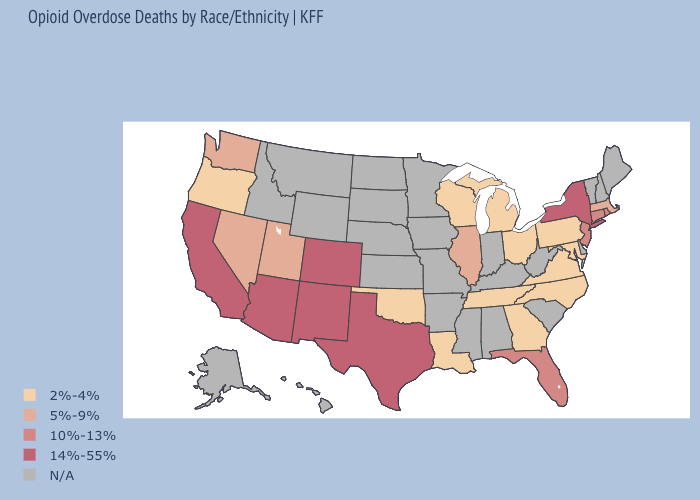Among the states that border Massachusetts , does Rhode Island have the highest value?
Concise answer only. No. Name the states that have a value in the range 2%-4%?
Answer briefly. Georgia, Louisiana, Maryland, Michigan, North Carolina, Ohio, Oklahoma, Oregon, Pennsylvania, Tennessee, Virginia, Wisconsin. Does the first symbol in the legend represent the smallest category?
Short answer required. Yes. Among the states that border Kansas , which have the highest value?
Write a very short answer. Colorado. What is the highest value in the MidWest ?
Keep it brief. 5%-9%. Name the states that have a value in the range N/A?
Give a very brief answer. Alabama, Alaska, Arkansas, Delaware, Hawaii, Idaho, Indiana, Iowa, Kansas, Kentucky, Maine, Minnesota, Mississippi, Missouri, Montana, Nebraska, New Hampshire, North Dakota, South Carolina, South Dakota, Vermont, West Virginia, Wyoming. What is the value of Mississippi?
Answer briefly. N/A. What is the value of Connecticut?
Answer briefly. 10%-13%. Name the states that have a value in the range 2%-4%?
Concise answer only. Georgia, Louisiana, Maryland, Michigan, North Carolina, Ohio, Oklahoma, Oregon, Pennsylvania, Tennessee, Virginia, Wisconsin. What is the value of Mississippi?
Answer briefly. N/A. Name the states that have a value in the range 2%-4%?
Quick response, please. Georgia, Louisiana, Maryland, Michigan, North Carolina, Ohio, Oklahoma, Oregon, Pennsylvania, Tennessee, Virginia, Wisconsin. What is the highest value in the Northeast ?
Keep it brief. 14%-55%. 